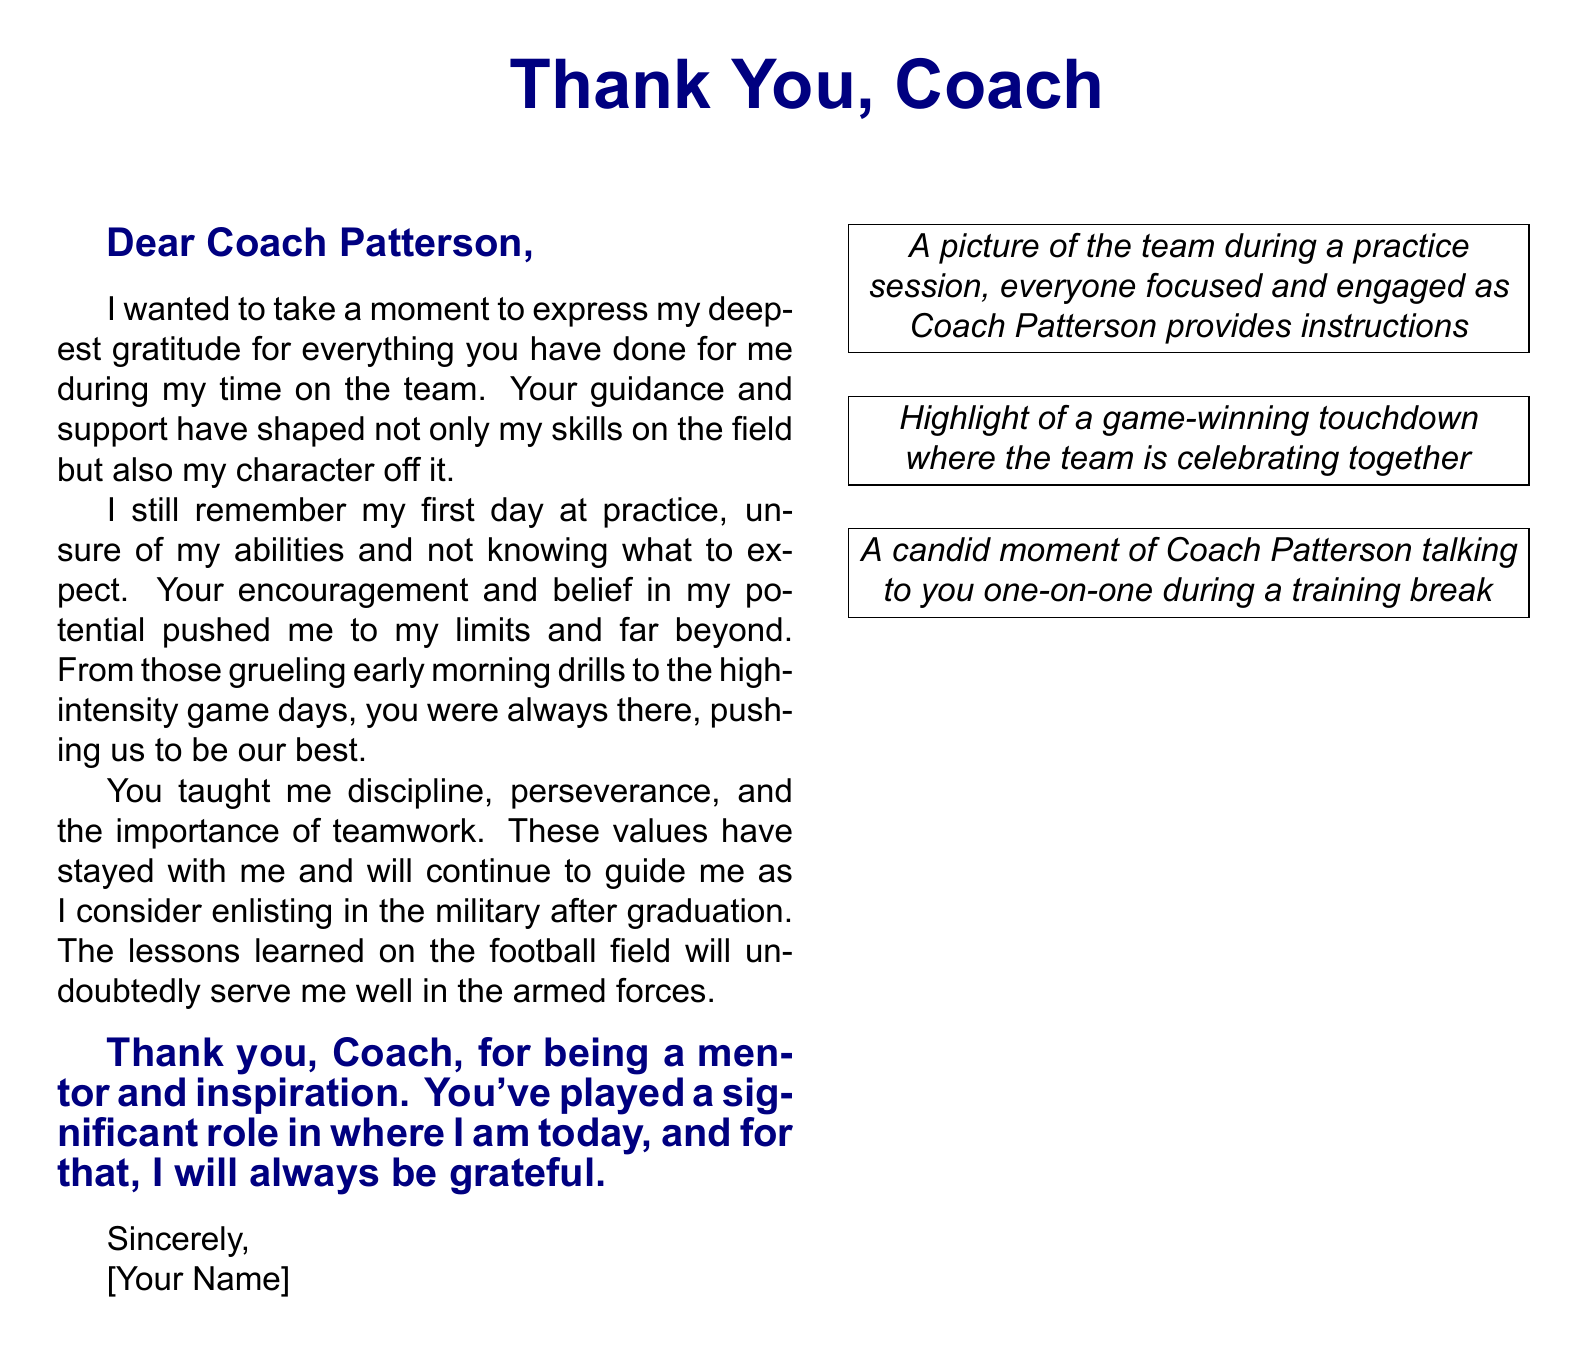What is the coach's name? The coach's name is mentioned in the greeting as Coach Patterson.
Answer: Coach Patterson What is the main color used for the text? The main color used for the text is navy blue, as defined at the beginning of the document.
Answer: Navy blue What values did the coach teach? The coach taught discipline, perseverance, and teamwork, which are highlighted in the note.
Answer: Discipline, perseverance, teamwork What type of document is this? The document is a greeting card expressing gratitude to a coach, as indicated by the title and content.
Answer: Greeting card How many game highlights are mentioned? The number of game highlights mentioned in the visual description is two, both showcasing important moments in the team's journey.
Answer: Two What is the purpose of this document? The purpose of this document is to thank and acknowledge the coach's impact on the player's skills and character.
Answer: Thank you What specific moment is highlighted in the first image? The first image highlights a practice session where the team is focused and engaged with instructions from Coach Patterson.
Answer: Practice session What kind of moment does the last image capture? The last image captures a candid moment of one-on-one conversation between the player and Coach Patterson.
Answer: One-on-one conversation 